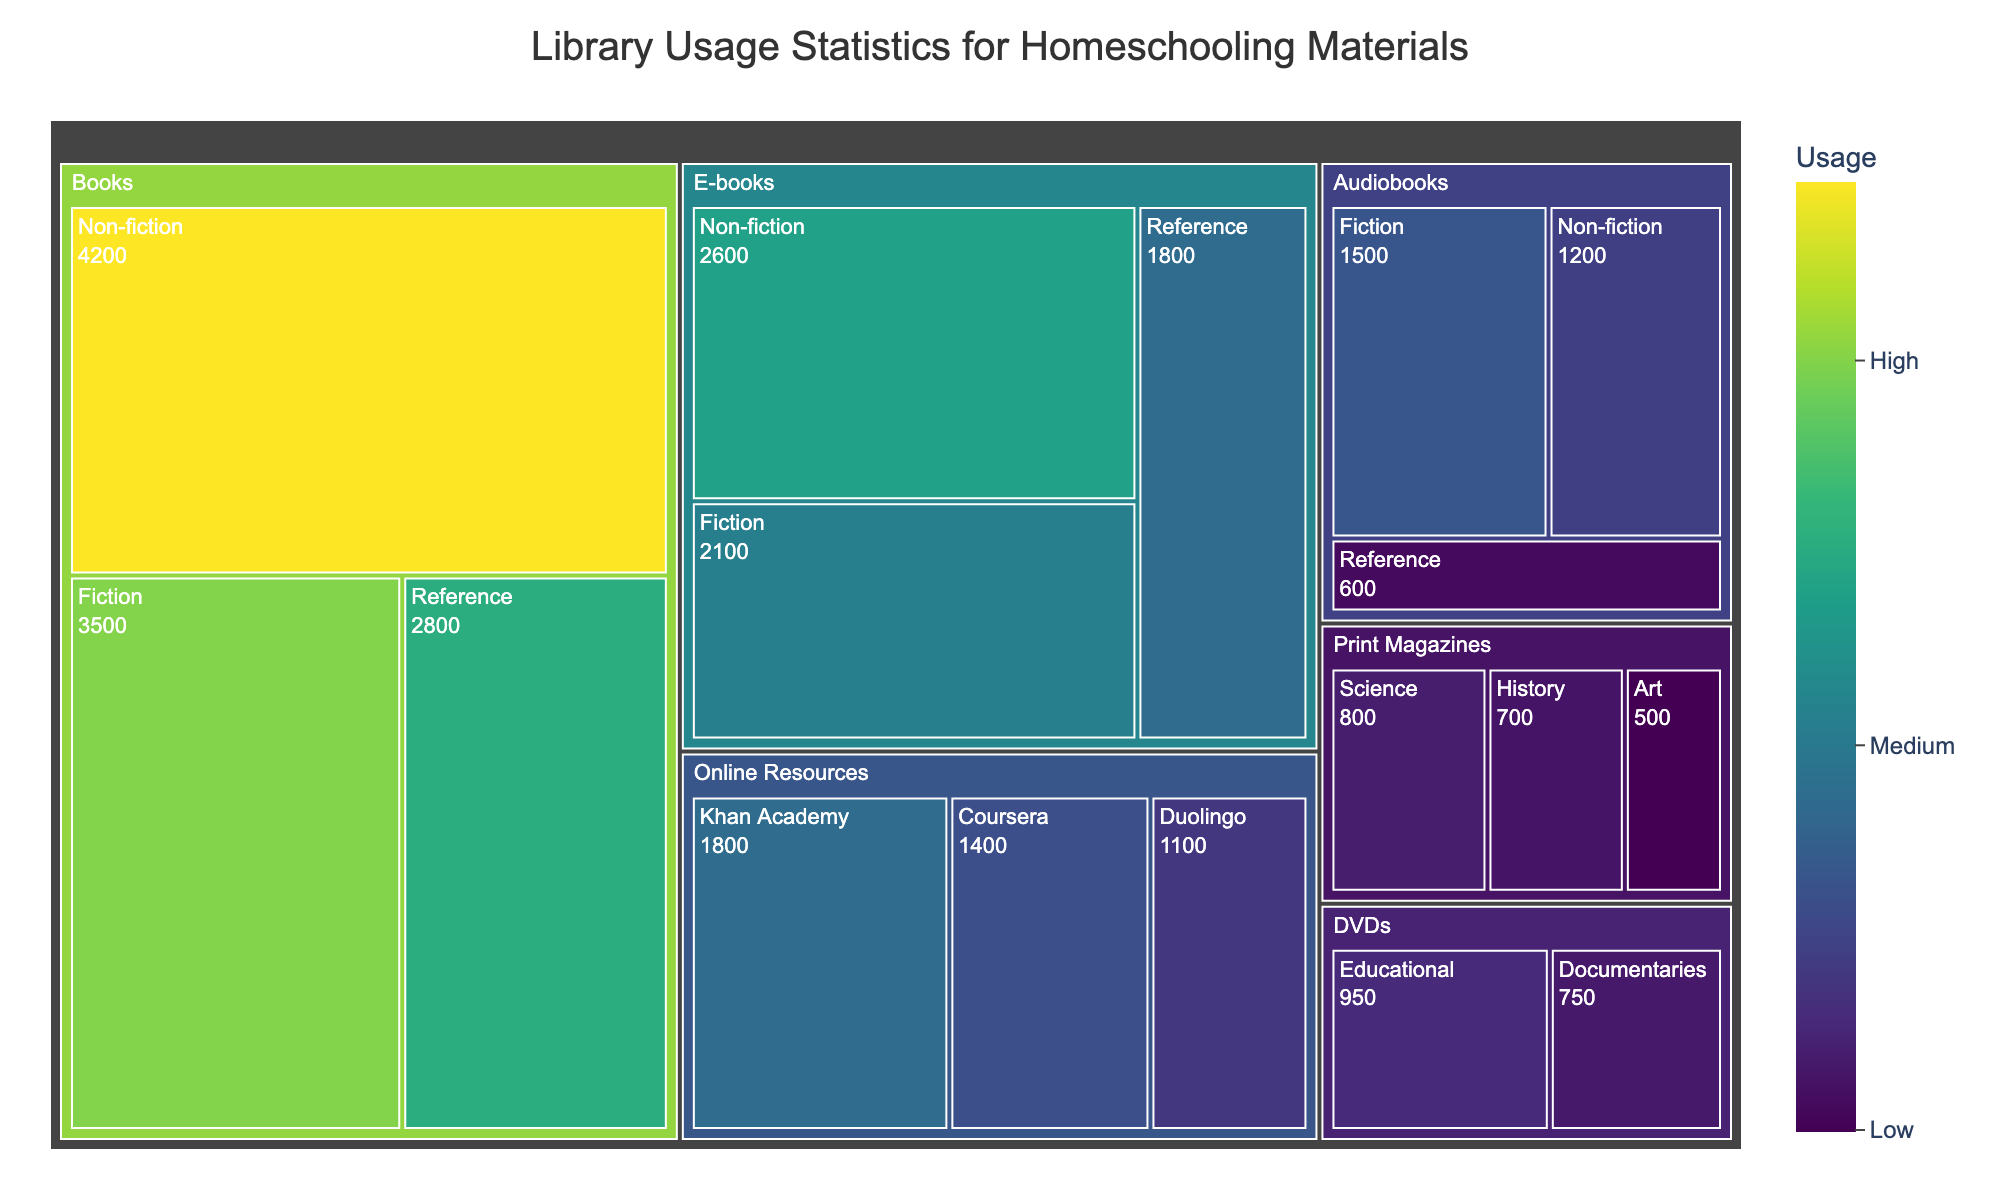Which format has the highest overall usage? Sum the usage of all categories within each format and compare. Books have the highest overall usage with 3500 (Fiction) + 4200 (Non-fiction) + 2800 (Reference) = 10500. No other format reaches this total.
Answer: Books Which category under Books has the highest usage? Look at the usage data for each category under Books. Non-fiction has 4200, which is higher than Fiction (3500) and Reference (2800).
Answer: Non-fiction What is the total usage of E-books? Sum the usage of all categories under E-books: 2100 (Fiction) + 2600 (Non-fiction) + 1800 (Reference) = 6500.
Answer: 6500 Which format has the lowest usage in the Non-fiction category? Compare the Non-fiction usage across all formats: Books (4200), E-books (2600), Audiobooks (1200). Audiobooks has the lowest at 1200.
Answer: Audiobooks How does the usage of Print Magazines in the Science category compare to the usage of Online Resources for Khan Academy? Compare the usage values: Print Magazines (Science) is 800, Online Resources (Khan Academy) is 1800. Khan Academy has higher usage.
Answer: Khan Academy What is the total usage of all Online Resources? Sum the usage of all categories under Online Resources: 1800 (Khan Academy) + 1400 (Coursera) + 1100 (Duolingo) = 4300.
Answer: 4300 Which format has the highest usage in the Reference category? Compare the Reference usage across all formats: Books (2800), E-books (1800), Audiobooks (600). Books has the highest usage at 2800.
Answer: Books Which format has the highest usage for educational DVDs versus Online Resources for educational purposes? DVDs (Educational) has a usage of 950, Online Resources (Khan Academy) has a usage of 1800. Online Resources (Khan Academy) has higher usage at 1800.
Answer: Online Resources (Khan Academy) Which category within Print Magazines has the lowest usage? Compare the usage data for each category under Print Magazines: Science (800), History (700), Art (500). Art has the lowest at 500.
Answer: Art What is the total usage of Audiobooks across all categories? Sum the usage for Fiction, Non-fiction, and Reference: 1500 (Fiction) + 1200 (Non-fiction) + 600 (Reference) = 3300.
Answer: 3300 